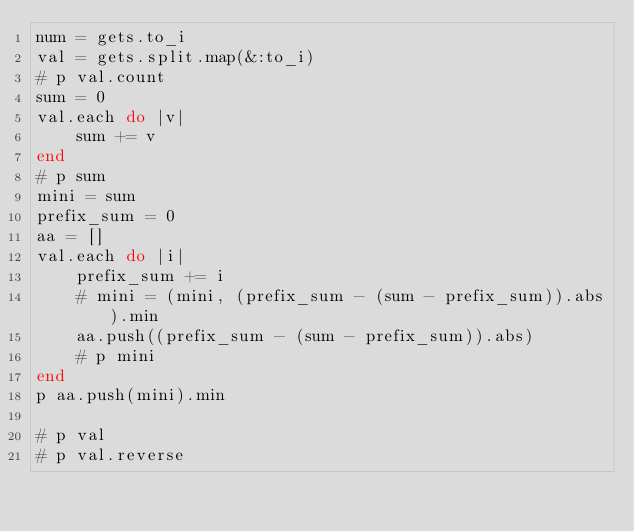<code> <loc_0><loc_0><loc_500><loc_500><_Ruby_>num = gets.to_i
val = gets.split.map(&:to_i)
# p val.count
sum = 0
val.each do |v|
    sum += v
end
# p sum
mini = sum
prefix_sum = 0
aa = []
val.each do |i|
    prefix_sum += i
    # mini = (mini, (prefix_sum - (sum - prefix_sum)).abs).min
    aa.push((prefix_sum - (sum - prefix_sum)).abs)
    # p mini
end
p aa.push(mini).min

# p val
# p val.reverse</code> 